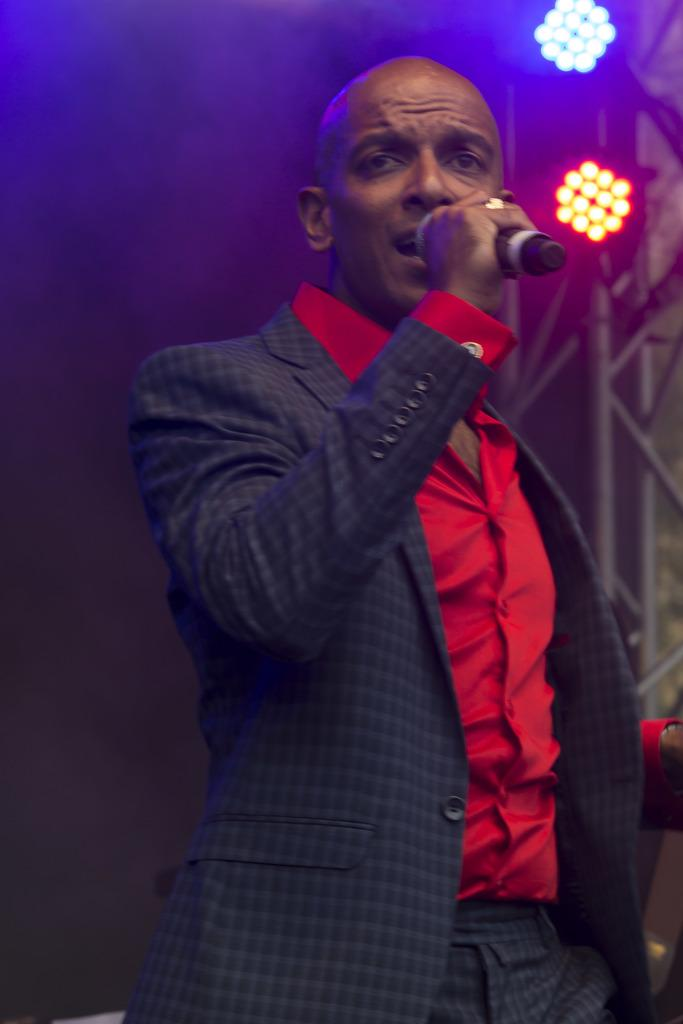Who is the main subject in the image? There is a man in the image. What is the man holding in the image? The man is holding a microphone. What is the man wearing in the image? The man is wearing a coat. What can be seen on the right side of the image? There are lights on the right side of the image. What time of day is it in the image, considering the position of the moon? There is no moon present in the image, so it is not possible to determine the time of day based on its position. 